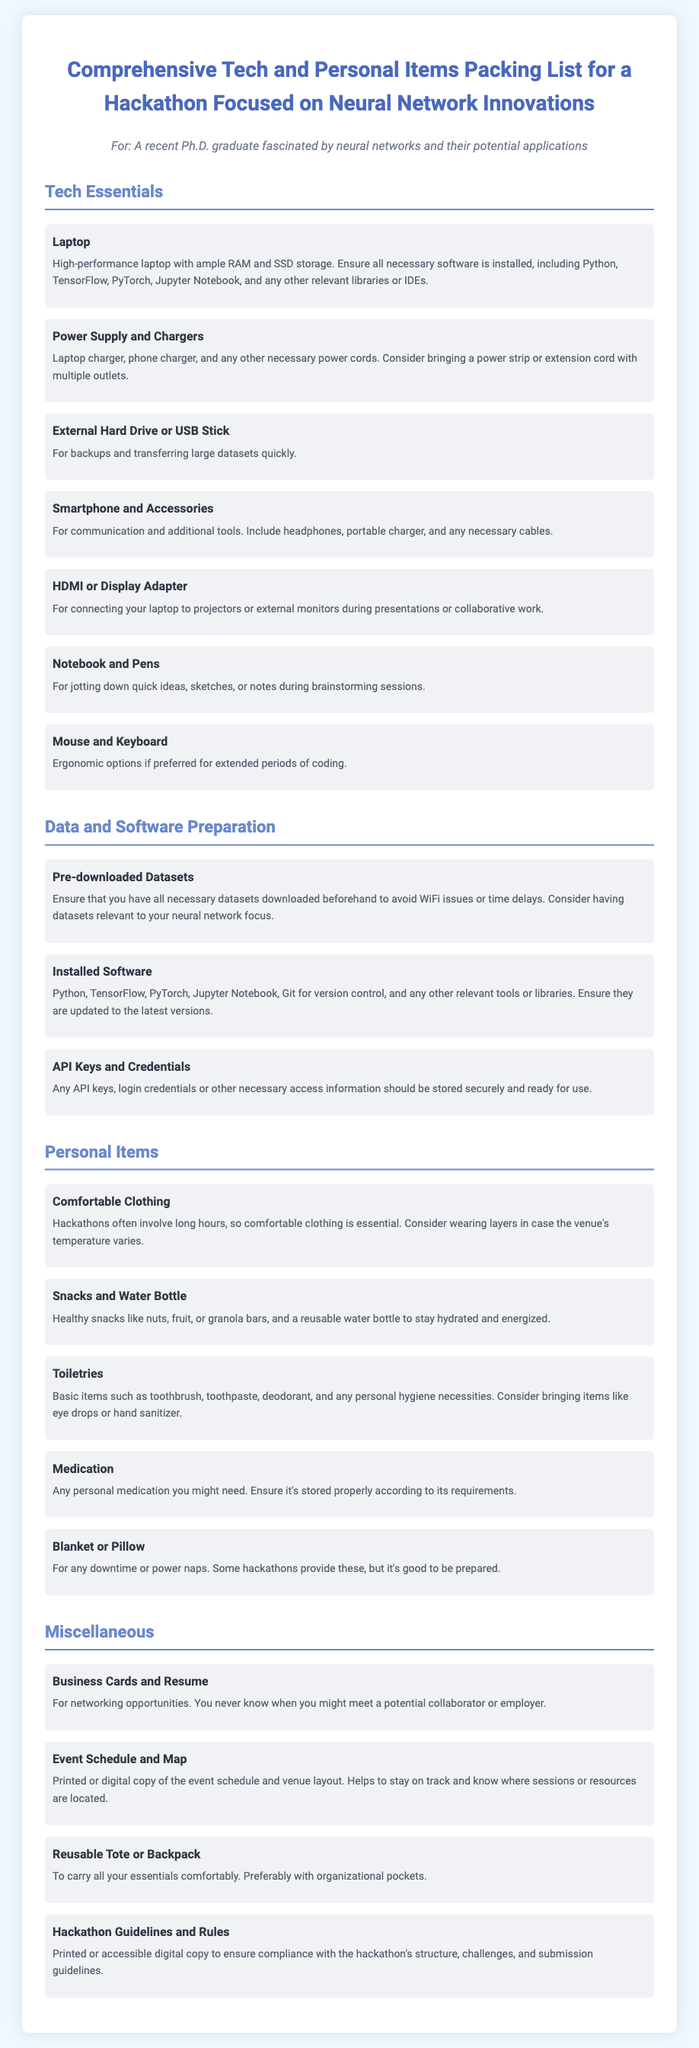what is the title of the document? The title is stated at the beginning of the document and encapsulates the main subject.
Answer: Comprehensive Tech and Personal Items Packing List for a Hackathon Focused on Neural Network Innovations how many categories are in the packing list? The categories are addressed in separate sections under technology essentials, data preparation, personal items, and miscellaneous.
Answer: Four what is one item listed in the Tech Essentials? The items under Tech Essentials are explicitly listed in a bullet format, with the first item mentioned.
Answer: Laptop what should you bring to stay hydrated? The packing list includes personal items that ensure nourishment and hydration, specifying the need for a certain item.
Answer: Water Bottle what is recommended for note-taking during the hackathon? The document suggests a specific item for jotting down notes, important for capturing ideas.
Answer: Notebook and Pens what type of clothing is suggested for the hackathon? The document advises on clothing that suits the long hours typically associated with hackathons.
Answer: Comfortable Clothing name a recommended personal hygiene item. The list outlines essential personal items that contribute to hygiene, with one explicitly mentioned for clarity.
Answer: Toothbrush how should datasets be prepared before the hackathon? The document provides a specific instruction regarding the preparation of datasets prior to the event to ensure efficiency.
Answer: Pre-downloaded Datasets what can be used for networking opportunities? There is a particular item suggested in the miscellaneous section for building professional connections.
Answer: Business Cards and Resume 